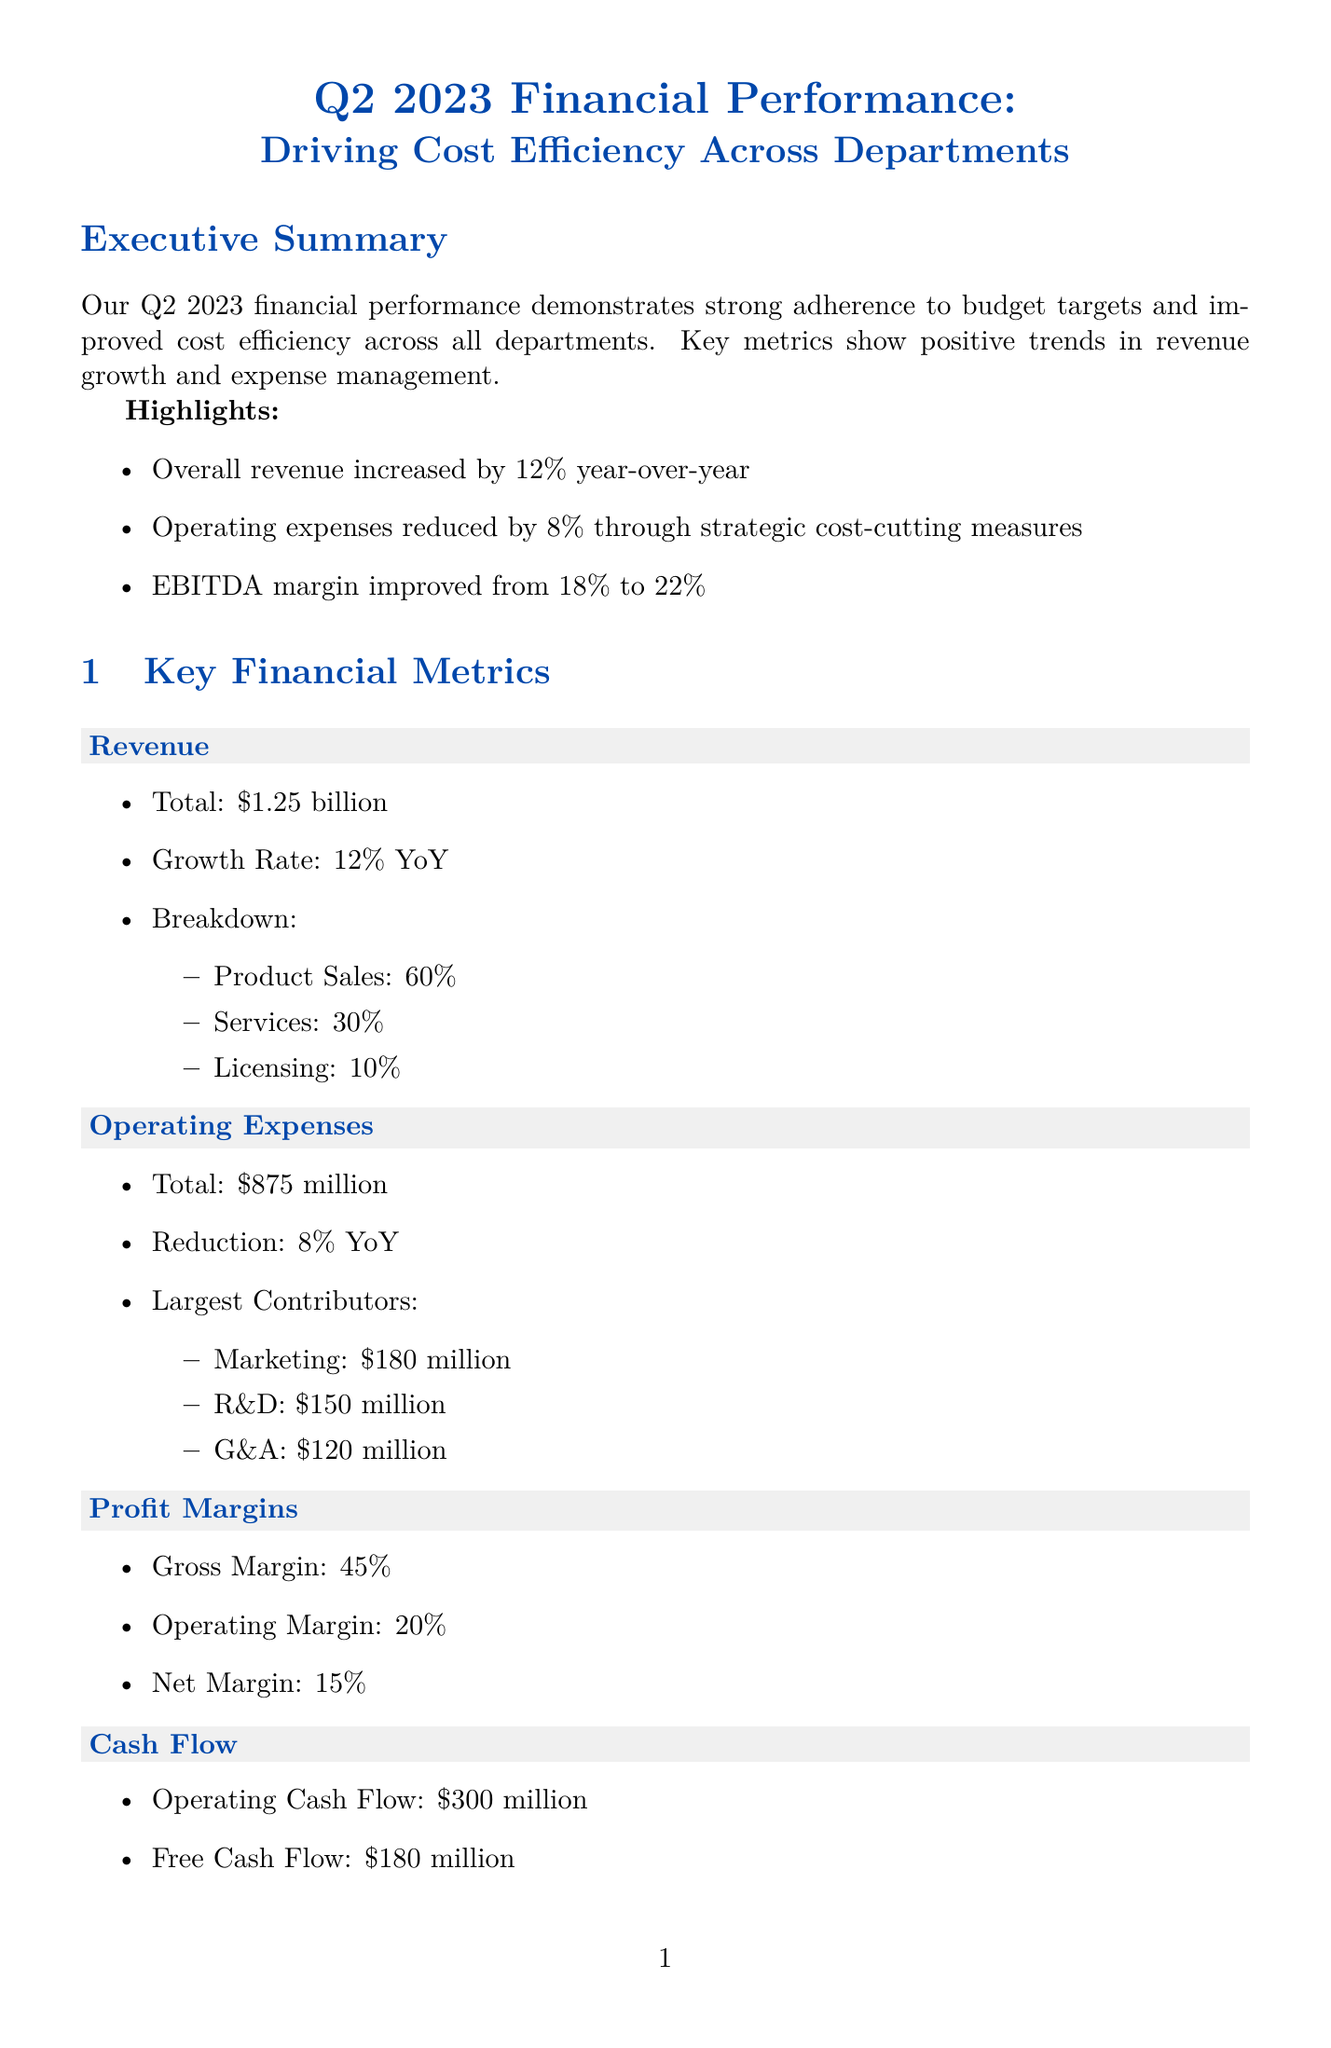What is the overall revenue increase percentage? The revenue increase percentage is provided in the highlights section of the document, which states a 12% increase year-over-year.
Answer: 12% What are the largest contributors to operating expenses? The document lists the components contributing to operating expenses, specifically Marketing, R&D, and G&A.
Answer: Marketing, R&D, G&A What is the overall budget adherence percentage? The overall budget adherence is mentioned in the budget adherence statistics section of the document as 96.5%.
Answer: 96.5% What is the projected savings from the Project Lean initiative? The Project Lean initiative states projected savings of $50 million annually in the cost efficiency initiatives section.
Answer: $50 million Which department had the highest budget adherence? The budget adherence statistics section indicates that Human Resources had the highest budget adherence at 99.1%.
Answer: Human Resources What is the full year revenue target? The full year revenue target is specified in the outlook and targets section of the document as $5.2 billion.
Answer: $5.2 billion What is the cash flow from operations? The cash flow from operations is listed in the cash flow section of the document as $300 million.
Answer: $300 million What is the full year EBITDA margin target? The full year EBITDA margin target is stated in the outlook and targets section as 24%.
Answer: 24% What are the main focus areas for cost reduction? The key focus areas for cost reduction are outlined in the outlook and targets section of the document, which includes expansion, optimization, and transformation initiatives.
Answer: Expansion, optimization, digital transformation 